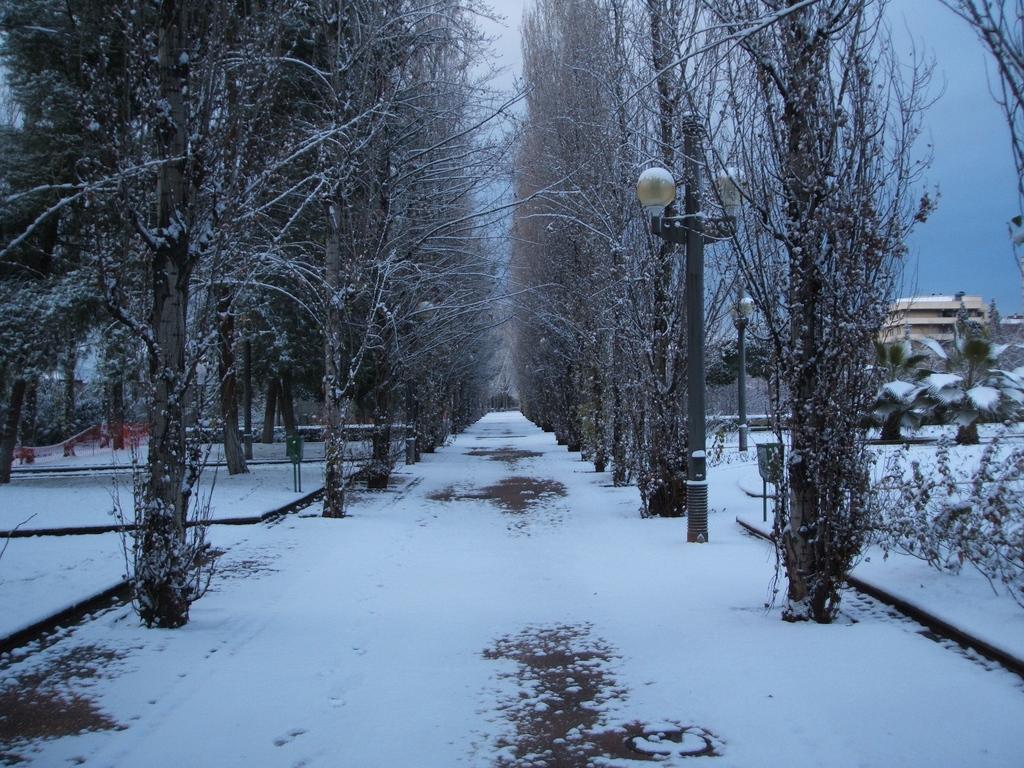In one or two sentences, can you explain what this image depicts? There is snow on the road and there are trees covered with snow on either sides of it. 